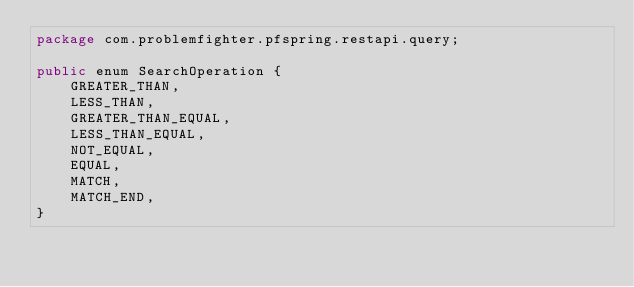Convert code to text. <code><loc_0><loc_0><loc_500><loc_500><_Java_>package com.problemfighter.pfspring.restapi.query;

public enum SearchOperation {
    GREATER_THAN,
    LESS_THAN,
    GREATER_THAN_EQUAL,
    LESS_THAN_EQUAL,
    NOT_EQUAL,
    EQUAL,
    MATCH,
    MATCH_END,
}
</code> 